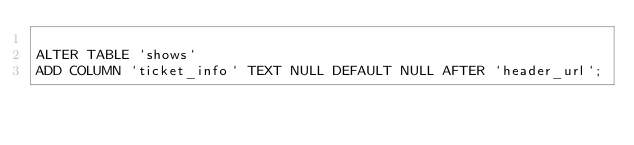<code> <loc_0><loc_0><loc_500><loc_500><_SQL_>
ALTER TABLE `shows` 
ADD COLUMN `ticket_info` TEXT NULL DEFAULT NULL AFTER `header_url`;
</code> 